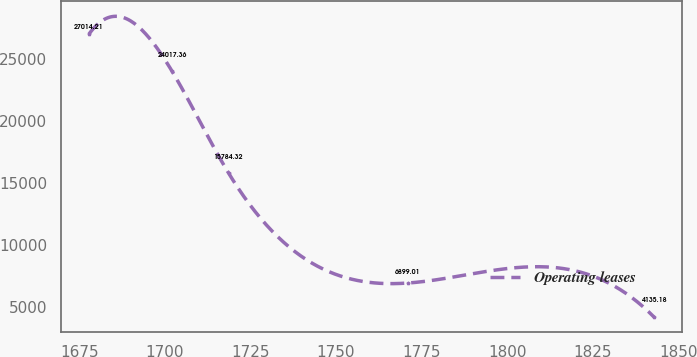Convert chart. <chart><loc_0><loc_0><loc_500><loc_500><line_chart><ecel><fcel>Operating leases<nl><fcel>1677.81<fcel>27014.2<nl><fcel>1702.12<fcel>24017.4<nl><fcel>1718.63<fcel>15784.3<nl><fcel>1771.03<fcel>6899.01<nl><fcel>1842.95<fcel>4135.18<nl></chart> 